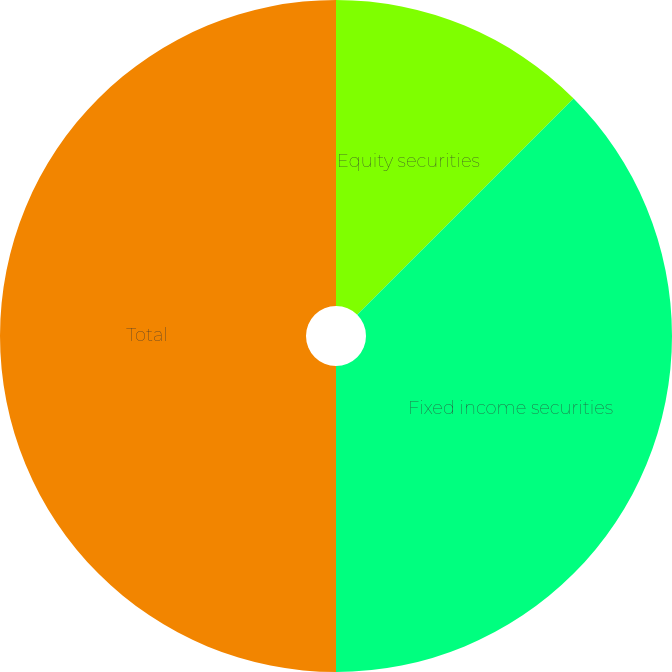Convert chart. <chart><loc_0><loc_0><loc_500><loc_500><pie_chart><fcel>Equity securities<fcel>Fixed income securities<fcel>Total<nl><fcel>12.5%<fcel>37.5%<fcel>50.0%<nl></chart> 